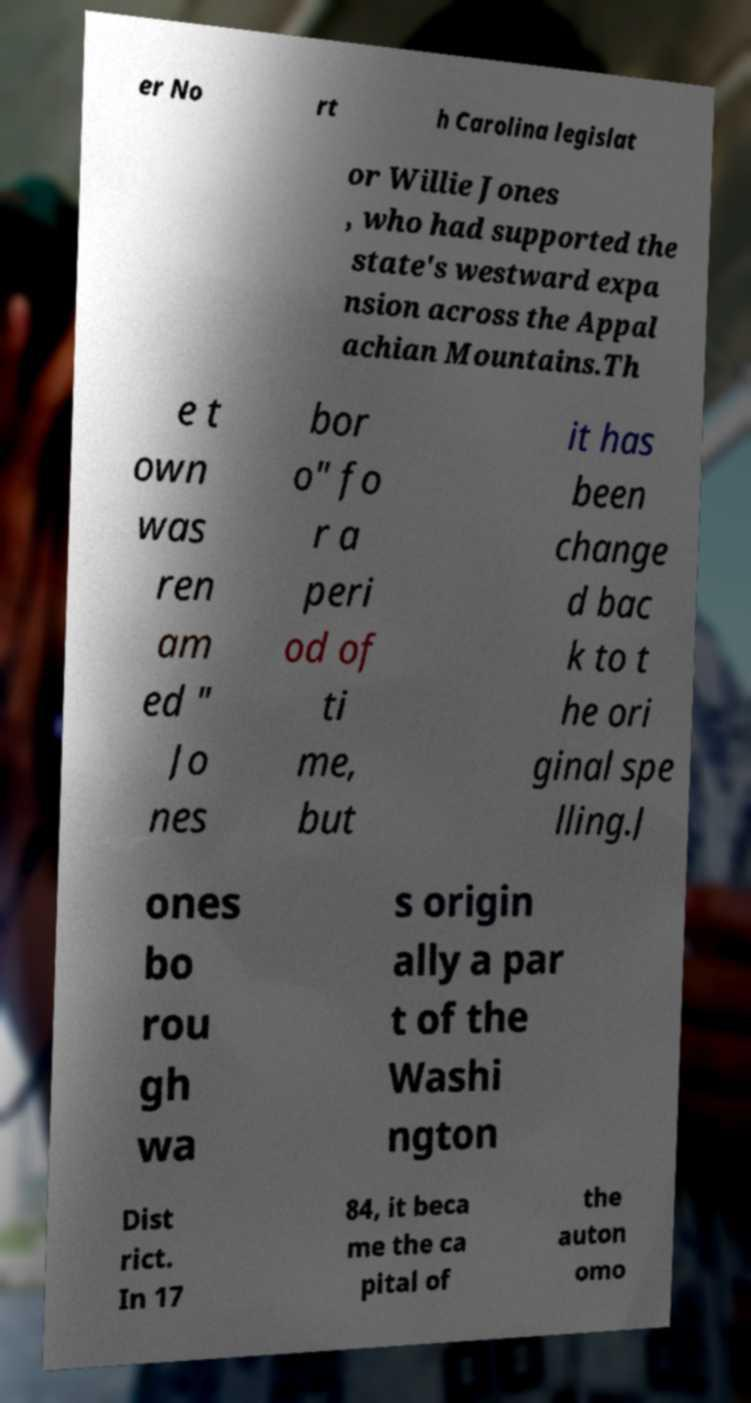Could you assist in decoding the text presented in this image and type it out clearly? er No rt h Carolina legislat or Willie Jones , who had supported the state's westward expa nsion across the Appal achian Mountains.Th e t own was ren am ed " Jo nes bor o" fo r a peri od of ti me, but it has been change d bac k to t he ori ginal spe lling.J ones bo rou gh wa s origin ally a par t of the Washi ngton Dist rict. In 17 84, it beca me the ca pital of the auton omo 